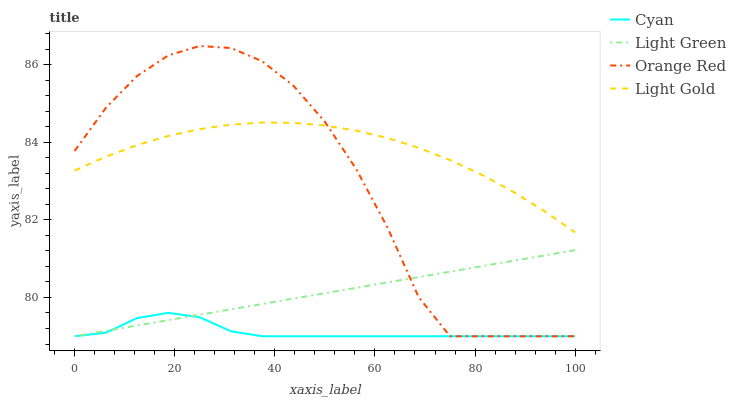Does Cyan have the minimum area under the curve?
Answer yes or no. Yes. Does Light Gold have the maximum area under the curve?
Answer yes or no. Yes. Does Orange Red have the minimum area under the curve?
Answer yes or no. No. Does Orange Red have the maximum area under the curve?
Answer yes or no. No. Is Light Green the smoothest?
Answer yes or no. Yes. Is Orange Red the roughest?
Answer yes or no. Yes. Is Light Gold the smoothest?
Answer yes or no. No. Is Light Gold the roughest?
Answer yes or no. No. Does Cyan have the lowest value?
Answer yes or no. Yes. Does Light Gold have the lowest value?
Answer yes or no. No. Does Orange Red have the highest value?
Answer yes or no. Yes. Does Light Gold have the highest value?
Answer yes or no. No. Is Cyan less than Light Gold?
Answer yes or no. Yes. Is Light Gold greater than Cyan?
Answer yes or no. Yes. Does Light Green intersect Cyan?
Answer yes or no. Yes. Is Light Green less than Cyan?
Answer yes or no. No. Is Light Green greater than Cyan?
Answer yes or no. No. Does Cyan intersect Light Gold?
Answer yes or no. No. 